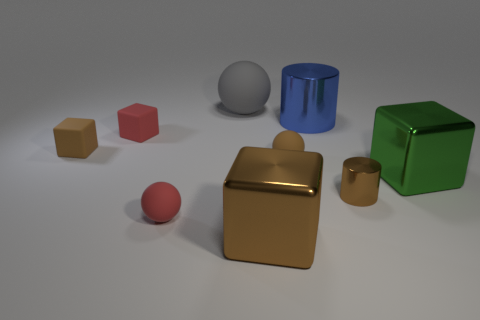What is the material of the tiny block that is in front of the small red block?
Your answer should be very brief. Rubber. Is the gray matte thing the same size as the green metal cube?
Provide a short and direct response. Yes. Is the number of small brown rubber things on the right side of the red matte cube greater than the number of big blue rubber blocks?
Offer a very short reply. Yes. There is a blue cylinder that is made of the same material as the large green thing; what is its size?
Provide a short and direct response. Large. Are there any green metal things behind the small cylinder?
Your response must be concise. Yes. Does the large brown object have the same shape as the green thing?
Your answer should be very brief. Yes. What size is the shiny block that is to the right of the large brown cube that is on the right side of the small red thing behind the brown rubber ball?
Make the answer very short. Large. What is the material of the green thing?
Keep it short and to the point. Metal. The matte ball that is the same color as the small metallic cylinder is what size?
Make the answer very short. Small. Does the tiny metallic object have the same shape as the red thing in front of the small brown shiny thing?
Your response must be concise. No. 